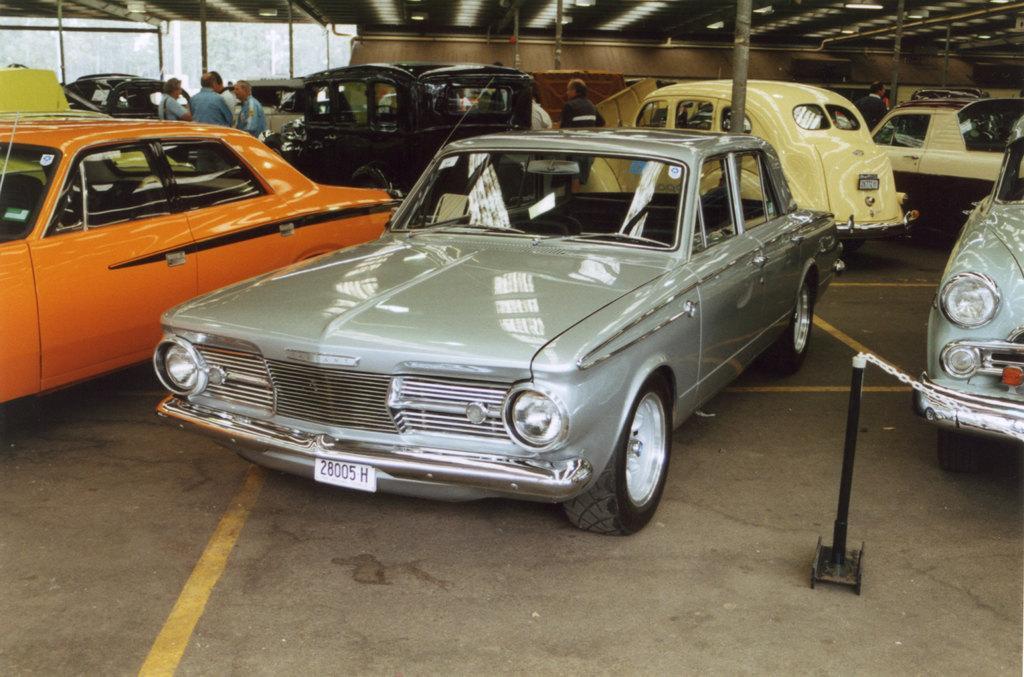Could you give a brief overview of what you see in this image? In the picture we can see a car shed with some cars are parked on the path which are orange, cream, gray and some people standing in the background and standing and we can see some poles to the shed. 